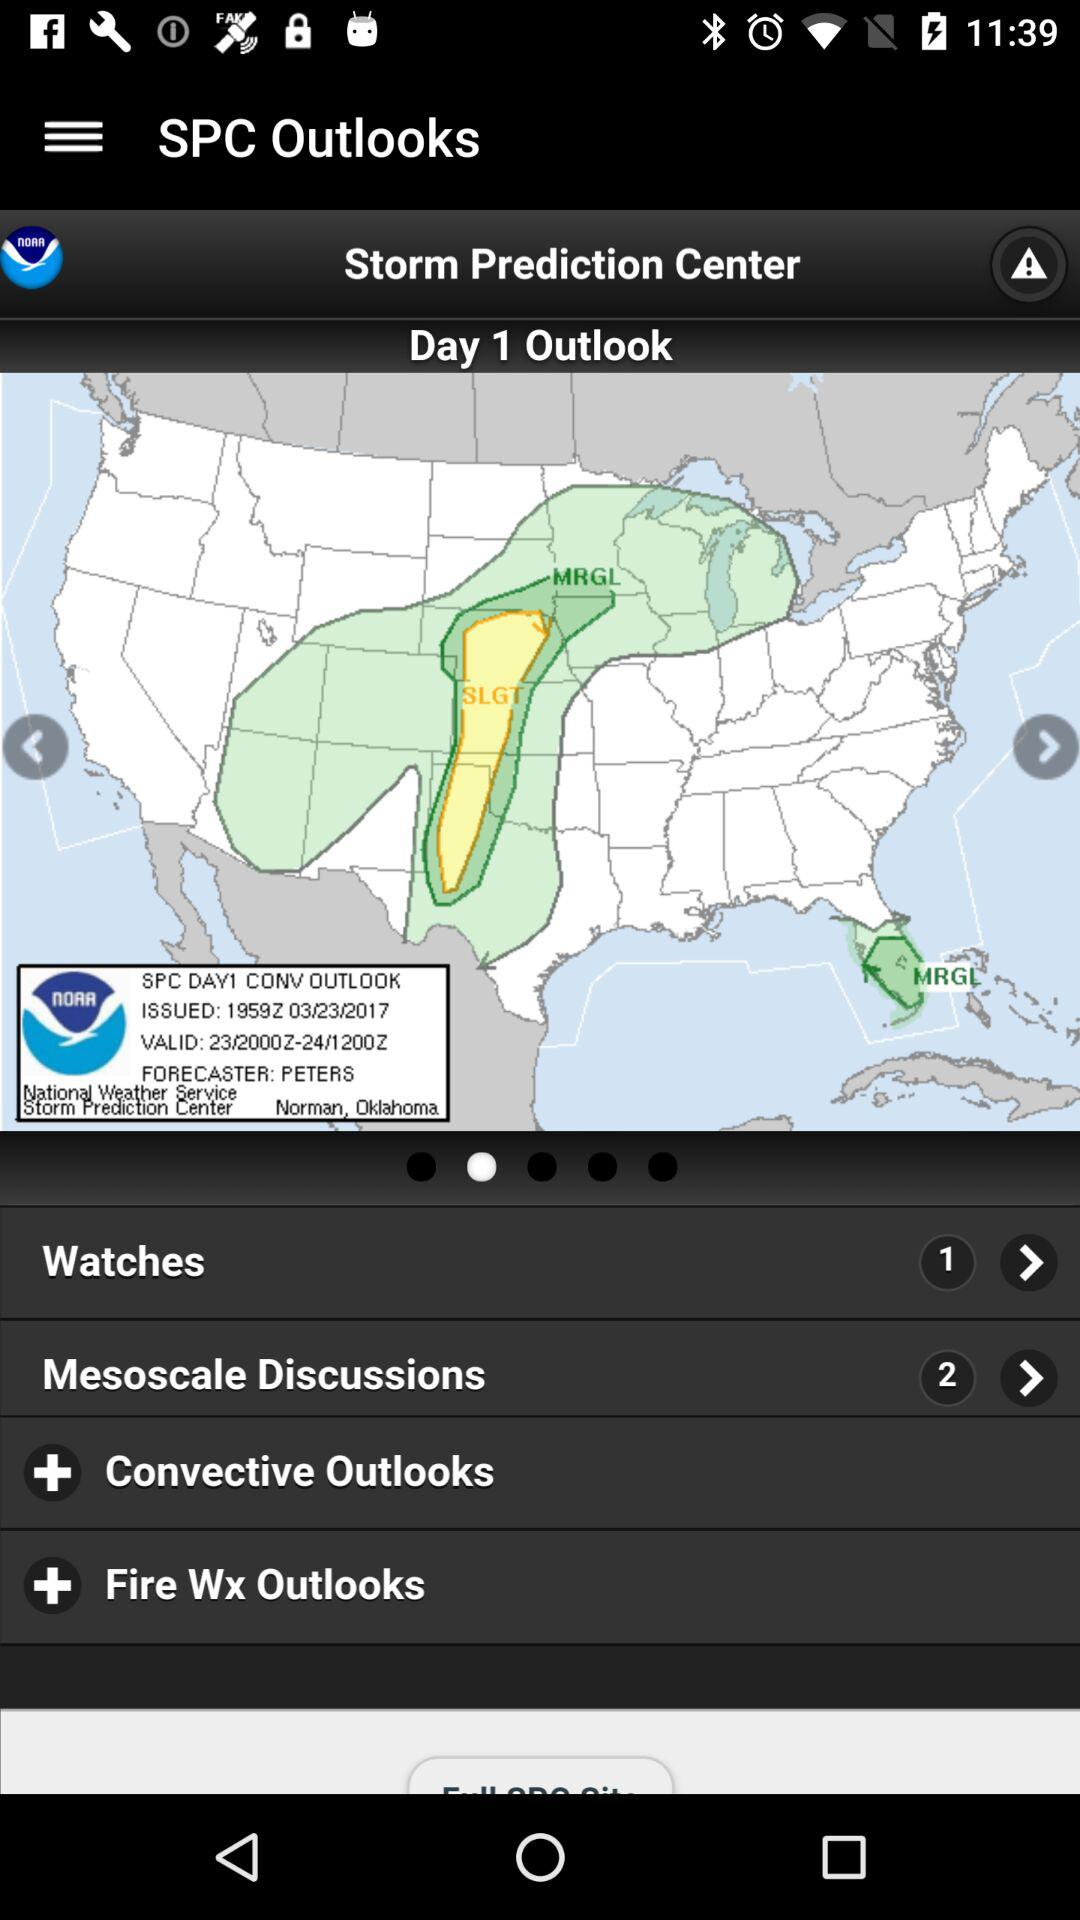How many different mesoscales are being discussed? There are 2 mesoscales that are being discussed. 